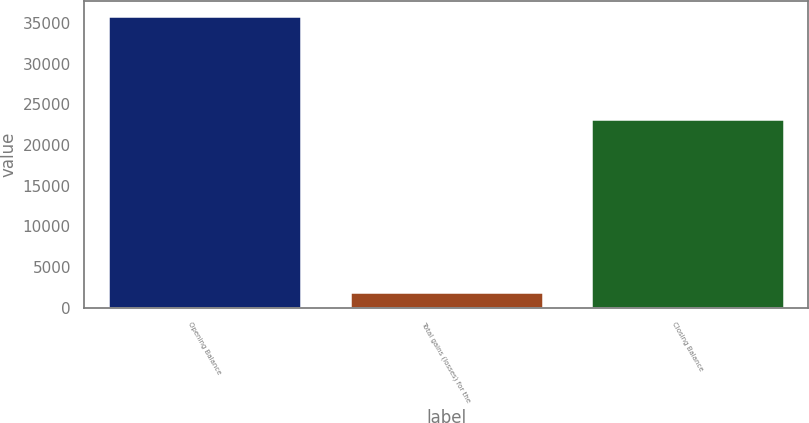<chart> <loc_0><loc_0><loc_500><loc_500><bar_chart><fcel>Opening Balance<fcel>Total gains (losses) for the<fcel>Closing Balance<nl><fcel>35852<fcel>1897<fcel>23156<nl></chart> 